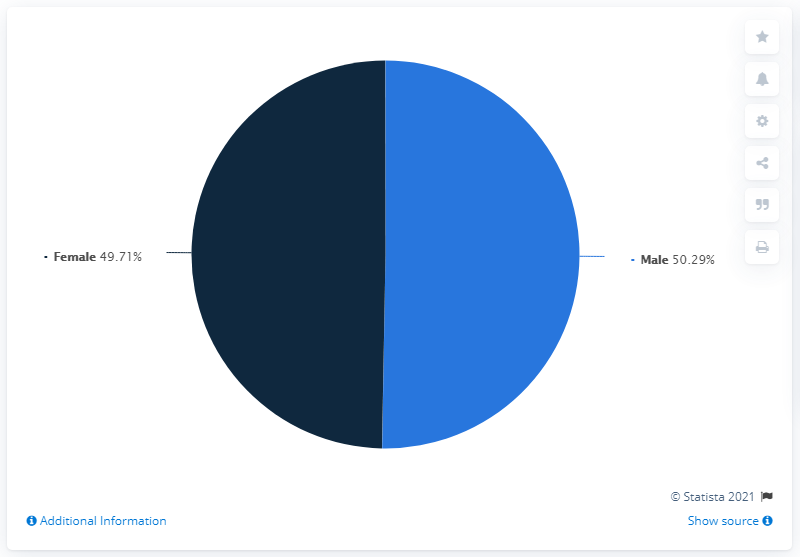Specify some key components in this picture. According to data, 50.29% of patients who passed away from COVID-19 were male. The difference in death percentage between two populations is 0.58. The gender with the highest deaths is male. 